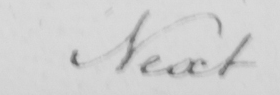What text is written in this handwritten line? Next 